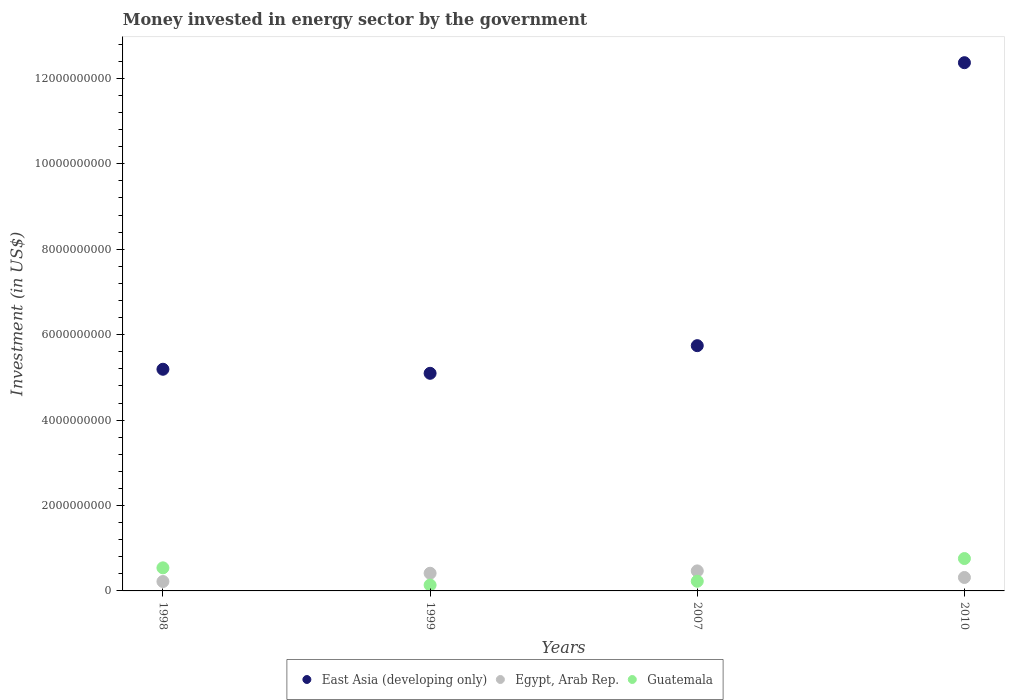Is the number of dotlines equal to the number of legend labels?
Your answer should be very brief. Yes. What is the money spent in energy sector in Guatemala in 1998?
Your answer should be compact. 5.40e+08. Across all years, what is the maximum money spent in energy sector in East Asia (developing only)?
Keep it short and to the point. 1.24e+1. Across all years, what is the minimum money spent in energy sector in Egypt, Arab Rep.?
Your answer should be very brief. 2.20e+08. In which year was the money spent in energy sector in Egypt, Arab Rep. maximum?
Offer a terse response. 2007. In which year was the money spent in energy sector in Guatemala minimum?
Your answer should be compact. 1999. What is the total money spent in energy sector in Egypt, Arab Rep. in the graph?
Your response must be concise. 1.42e+09. What is the difference between the money spent in energy sector in Egypt, Arab Rep. in 1999 and that in 2007?
Make the answer very short. -5.50e+07. What is the difference between the money spent in energy sector in Guatemala in 1998 and the money spent in energy sector in East Asia (developing only) in 2010?
Keep it short and to the point. -1.18e+1. What is the average money spent in energy sector in Egypt, Arab Rep. per year?
Your response must be concise. 3.54e+08. In the year 1999, what is the difference between the money spent in energy sector in Guatemala and money spent in energy sector in Egypt, Arab Rep.?
Your answer should be compact. -2.76e+08. What is the ratio of the money spent in energy sector in Egypt, Arab Rep. in 1998 to that in 1999?
Offer a terse response. 0.53. Is the money spent in energy sector in East Asia (developing only) in 1998 less than that in 1999?
Give a very brief answer. No. Is the difference between the money spent in energy sector in Guatemala in 1999 and 2007 greater than the difference between the money spent in energy sector in Egypt, Arab Rep. in 1999 and 2007?
Offer a very short reply. No. What is the difference between the highest and the second highest money spent in energy sector in Guatemala?
Make the answer very short. 2.18e+08. What is the difference between the highest and the lowest money spent in energy sector in Guatemala?
Your answer should be compact. 6.20e+08. Is it the case that in every year, the sum of the money spent in energy sector in Egypt, Arab Rep. and money spent in energy sector in East Asia (developing only)  is greater than the money spent in energy sector in Guatemala?
Provide a succinct answer. Yes. Does the money spent in energy sector in Guatemala monotonically increase over the years?
Provide a short and direct response. No. Is the money spent in energy sector in Guatemala strictly less than the money spent in energy sector in Egypt, Arab Rep. over the years?
Give a very brief answer. No. How many years are there in the graph?
Offer a terse response. 4. Are the values on the major ticks of Y-axis written in scientific E-notation?
Ensure brevity in your answer.  No. Does the graph contain grids?
Your answer should be very brief. No. How many legend labels are there?
Keep it short and to the point. 3. How are the legend labels stacked?
Your answer should be very brief. Horizontal. What is the title of the graph?
Your response must be concise. Money invested in energy sector by the government. Does "Small states" appear as one of the legend labels in the graph?
Keep it short and to the point. No. What is the label or title of the X-axis?
Your response must be concise. Years. What is the label or title of the Y-axis?
Your answer should be very brief. Investment (in US$). What is the Investment (in US$) in East Asia (developing only) in 1998?
Provide a succinct answer. 5.19e+09. What is the Investment (in US$) in Egypt, Arab Rep. in 1998?
Provide a succinct answer. 2.20e+08. What is the Investment (in US$) in Guatemala in 1998?
Ensure brevity in your answer.  5.40e+08. What is the Investment (in US$) of East Asia (developing only) in 1999?
Provide a short and direct response. 5.10e+09. What is the Investment (in US$) of Egypt, Arab Rep. in 1999?
Offer a terse response. 4.14e+08. What is the Investment (in US$) of Guatemala in 1999?
Your answer should be compact. 1.38e+08. What is the Investment (in US$) in East Asia (developing only) in 2007?
Offer a terse response. 5.74e+09. What is the Investment (in US$) of Egypt, Arab Rep. in 2007?
Your response must be concise. 4.69e+08. What is the Investment (in US$) in Guatemala in 2007?
Give a very brief answer. 2.27e+08. What is the Investment (in US$) of East Asia (developing only) in 2010?
Give a very brief answer. 1.24e+1. What is the Investment (in US$) of Egypt, Arab Rep. in 2010?
Provide a short and direct response. 3.15e+08. What is the Investment (in US$) in Guatemala in 2010?
Provide a short and direct response. 7.58e+08. Across all years, what is the maximum Investment (in US$) in East Asia (developing only)?
Ensure brevity in your answer.  1.24e+1. Across all years, what is the maximum Investment (in US$) of Egypt, Arab Rep.?
Your response must be concise. 4.69e+08. Across all years, what is the maximum Investment (in US$) of Guatemala?
Your answer should be compact. 7.58e+08. Across all years, what is the minimum Investment (in US$) of East Asia (developing only)?
Ensure brevity in your answer.  5.10e+09. Across all years, what is the minimum Investment (in US$) of Egypt, Arab Rep.?
Give a very brief answer. 2.20e+08. Across all years, what is the minimum Investment (in US$) of Guatemala?
Ensure brevity in your answer.  1.38e+08. What is the total Investment (in US$) of East Asia (developing only) in the graph?
Ensure brevity in your answer.  2.84e+1. What is the total Investment (in US$) of Egypt, Arab Rep. in the graph?
Offer a very short reply. 1.42e+09. What is the total Investment (in US$) of Guatemala in the graph?
Keep it short and to the point. 1.66e+09. What is the difference between the Investment (in US$) of East Asia (developing only) in 1998 and that in 1999?
Your answer should be compact. 9.47e+07. What is the difference between the Investment (in US$) of Egypt, Arab Rep. in 1998 and that in 1999?
Your answer should be very brief. -1.94e+08. What is the difference between the Investment (in US$) in Guatemala in 1998 and that in 1999?
Your answer should be very brief. 4.03e+08. What is the difference between the Investment (in US$) in East Asia (developing only) in 1998 and that in 2007?
Offer a terse response. -5.53e+08. What is the difference between the Investment (in US$) in Egypt, Arab Rep. in 1998 and that in 2007?
Your answer should be very brief. -2.49e+08. What is the difference between the Investment (in US$) of Guatemala in 1998 and that in 2007?
Your answer should be compact. 3.14e+08. What is the difference between the Investment (in US$) of East Asia (developing only) in 1998 and that in 2010?
Offer a very short reply. -7.18e+09. What is the difference between the Investment (in US$) in Egypt, Arab Rep. in 1998 and that in 2010?
Offer a very short reply. -9.47e+07. What is the difference between the Investment (in US$) in Guatemala in 1998 and that in 2010?
Offer a very short reply. -2.18e+08. What is the difference between the Investment (in US$) of East Asia (developing only) in 1999 and that in 2007?
Your answer should be very brief. -6.47e+08. What is the difference between the Investment (in US$) of Egypt, Arab Rep. in 1999 and that in 2007?
Your response must be concise. -5.50e+07. What is the difference between the Investment (in US$) of Guatemala in 1999 and that in 2007?
Your response must be concise. -8.91e+07. What is the difference between the Investment (in US$) of East Asia (developing only) in 1999 and that in 2010?
Your response must be concise. -7.27e+09. What is the difference between the Investment (in US$) of Egypt, Arab Rep. in 1999 and that in 2010?
Provide a succinct answer. 9.93e+07. What is the difference between the Investment (in US$) of Guatemala in 1999 and that in 2010?
Your answer should be compact. -6.20e+08. What is the difference between the Investment (in US$) of East Asia (developing only) in 2007 and that in 2010?
Provide a short and direct response. -6.63e+09. What is the difference between the Investment (in US$) of Egypt, Arab Rep. in 2007 and that in 2010?
Ensure brevity in your answer.  1.54e+08. What is the difference between the Investment (in US$) in Guatemala in 2007 and that in 2010?
Your answer should be very brief. -5.31e+08. What is the difference between the Investment (in US$) of East Asia (developing only) in 1998 and the Investment (in US$) of Egypt, Arab Rep. in 1999?
Your answer should be compact. 4.78e+09. What is the difference between the Investment (in US$) of East Asia (developing only) in 1998 and the Investment (in US$) of Guatemala in 1999?
Give a very brief answer. 5.05e+09. What is the difference between the Investment (in US$) of Egypt, Arab Rep. in 1998 and the Investment (in US$) of Guatemala in 1999?
Keep it short and to the point. 8.23e+07. What is the difference between the Investment (in US$) of East Asia (developing only) in 1998 and the Investment (in US$) of Egypt, Arab Rep. in 2007?
Make the answer very short. 4.72e+09. What is the difference between the Investment (in US$) in East Asia (developing only) in 1998 and the Investment (in US$) in Guatemala in 2007?
Give a very brief answer. 4.96e+09. What is the difference between the Investment (in US$) of Egypt, Arab Rep. in 1998 and the Investment (in US$) of Guatemala in 2007?
Your answer should be very brief. -6.80e+06. What is the difference between the Investment (in US$) of East Asia (developing only) in 1998 and the Investment (in US$) of Egypt, Arab Rep. in 2010?
Ensure brevity in your answer.  4.88e+09. What is the difference between the Investment (in US$) in East Asia (developing only) in 1998 and the Investment (in US$) in Guatemala in 2010?
Your answer should be very brief. 4.43e+09. What is the difference between the Investment (in US$) of Egypt, Arab Rep. in 1998 and the Investment (in US$) of Guatemala in 2010?
Offer a terse response. -5.38e+08. What is the difference between the Investment (in US$) in East Asia (developing only) in 1999 and the Investment (in US$) in Egypt, Arab Rep. in 2007?
Make the answer very short. 4.63e+09. What is the difference between the Investment (in US$) of East Asia (developing only) in 1999 and the Investment (in US$) of Guatemala in 2007?
Your response must be concise. 4.87e+09. What is the difference between the Investment (in US$) of Egypt, Arab Rep. in 1999 and the Investment (in US$) of Guatemala in 2007?
Give a very brief answer. 1.87e+08. What is the difference between the Investment (in US$) in East Asia (developing only) in 1999 and the Investment (in US$) in Egypt, Arab Rep. in 2010?
Provide a short and direct response. 4.78e+09. What is the difference between the Investment (in US$) in East Asia (developing only) in 1999 and the Investment (in US$) in Guatemala in 2010?
Make the answer very short. 4.34e+09. What is the difference between the Investment (in US$) of Egypt, Arab Rep. in 1999 and the Investment (in US$) of Guatemala in 2010?
Ensure brevity in your answer.  -3.44e+08. What is the difference between the Investment (in US$) in East Asia (developing only) in 2007 and the Investment (in US$) in Egypt, Arab Rep. in 2010?
Offer a terse response. 5.43e+09. What is the difference between the Investment (in US$) of East Asia (developing only) in 2007 and the Investment (in US$) of Guatemala in 2010?
Your response must be concise. 4.98e+09. What is the difference between the Investment (in US$) of Egypt, Arab Rep. in 2007 and the Investment (in US$) of Guatemala in 2010?
Ensure brevity in your answer.  -2.89e+08. What is the average Investment (in US$) of East Asia (developing only) per year?
Provide a short and direct response. 7.10e+09. What is the average Investment (in US$) of Egypt, Arab Rep. per year?
Your answer should be very brief. 3.54e+08. What is the average Investment (in US$) in Guatemala per year?
Provide a short and direct response. 4.16e+08. In the year 1998, what is the difference between the Investment (in US$) of East Asia (developing only) and Investment (in US$) of Egypt, Arab Rep.?
Provide a succinct answer. 4.97e+09. In the year 1998, what is the difference between the Investment (in US$) in East Asia (developing only) and Investment (in US$) in Guatemala?
Offer a very short reply. 4.65e+09. In the year 1998, what is the difference between the Investment (in US$) of Egypt, Arab Rep. and Investment (in US$) of Guatemala?
Keep it short and to the point. -3.20e+08. In the year 1999, what is the difference between the Investment (in US$) in East Asia (developing only) and Investment (in US$) in Egypt, Arab Rep.?
Provide a short and direct response. 4.68e+09. In the year 1999, what is the difference between the Investment (in US$) of East Asia (developing only) and Investment (in US$) of Guatemala?
Give a very brief answer. 4.96e+09. In the year 1999, what is the difference between the Investment (in US$) in Egypt, Arab Rep. and Investment (in US$) in Guatemala?
Offer a terse response. 2.76e+08. In the year 2007, what is the difference between the Investment (in US$) in East Asia (developing only) and Investment (in US$) in Egypt, Arab Rep.?
Make the answer very short. 5.27e+09. In the year 2007, what is the difference between the Investment (in US$) in East Asia (developing only) and Investment (in US$) in Guatemala?
Provide a short and direct response. 5.52e+09. In the year 2007, what is the difference between the Investment (in US$) in Egypt, Arab Rep. and Investment (in US$) in Guatemala?
Your answer should be very brief. 2.42e+08. In the year 2010, what is the difference between the Investment (in US$) of East Asia (developing only) and Investment (in US$) of Egypt, Arab Rep.?
Your answer should be very brief. 1.21e+1. In the year 2010, what is the difference between the Investment (in US$) in East Asia (developing only) and Investment (in US$) in Guatemala?
Your response must be concise. 1.16e+1. In the year 2010, what is the difference between the Investment (in US$) of Egypt, Arab Rep. and Investment (in US$) of Guatemala?
Keep it short and to the point. -4.43e+08. What is the ratio of the Investment (in US$) in East Asia (developing only) in 1998 to that in 1999?
Ensure brevity in your answer.  1.02. What is the ratio of the Investment (in US$) of Egypt, Arab Rep. in 1998 to that in 1999?
Keep it short and to the point. 0.53. What is the ratio of the Investment (in US$) in Guatemala in 1998 to that in 1999?
Your answer should be very brief. 3.92. What is the ratio of the Investment (in US$) in East Asia (developing only) in 1998 to that in 2007?
Give a very brief answer. 0.9. What is the ratio of the Investment (in US$) in Egypt, Arab Rep. in 1998 to that in 2007?
Offer a terse response. 0.47. What is the ratio of the Investment (in US$) of Guatemala in 1998 to that in 2007?
Your response must be concise. 2.38. What is the ratio of the Investment (in US$) in East Asia (developing only) in 1998 to that in 2010?
Your answer should be very brief. 0.42. What is the ratio of the Investment (in US$) in Egypt, Arab Rep. in 1998 to that in 2010?
Your answer should be very brief. 0.7. What is the ratio of the Investment (in US$) of Guatemala in 1998 to that in 2010?
Provide a short and direct response. 0.71. What is the ratio of the Investment (in US$) in East Asia (developing only) in 1999 to that in 2007?
Ensure brevity in your answer.  0.89. What is the ratio of the Investment (in US$) in Egypt, Arab Rep. in 1999 to that in 2007?
Give a very brief answer. 0.88. What is the ratio of the Investment (in US$) in Guatemala in 1999 to that in 2007?
Make the answer very short. 0.61. What is the ratio of the Investment (in US$) of East Asia (developing only) in 1999 to that in 2010?
Ensure brevity in your answer.  0.41. What is the ratio of the Investment (in US$) in Egypt, Arab Rep. in 1999 to that in 2010?
Make the answer very short. 1.32. What is the ratio of the Investment (in US$) in Guatemala in 1999 to that in 2010?
Offer a very short reply. 0.18. What is the ratio of the Investment (in US$) of East Asia (developing only) in 2007 to that in 2010?
Make the answer very short. 0.46. What is the ratio of the Investment (in US$) of Egypt, Arab Rep. in 2007 to that in 2010?
Your answer should be compact. 1.49. What is the ratio of the Investment (in US$) of Guatemala in 2007 to that in 2010?
Give a very brief answer. 0.3. What is the difference between the highest and the second highest Investment (in US$) in East Asia (developing only)?
Your answer should be compact. 6.63e+09. What is the difference between the highest and the second highest Investment (in US$) of Egypt, Arab Rep.?
Your answer should be compact. 5.50e+07. What is the difference between the highest and the second highest Investment (in US$) of Guatemala?
Make the answer very short. 2.18e+08. What is the difference between the highest and the lowest Investment (in US$) in East Asia (developing only)?
Provide a short and direct response. 7.27e+09. What is the difference between the highest and the lowest Investment (in US$) of Egypt, Arab Rep.?
Keep it short and to the point. 2.49e+08. What is the difference between the highest and the lowest Investment (in US$) of Guatemala?
Provide a short and direct response. 6.20e+08. 